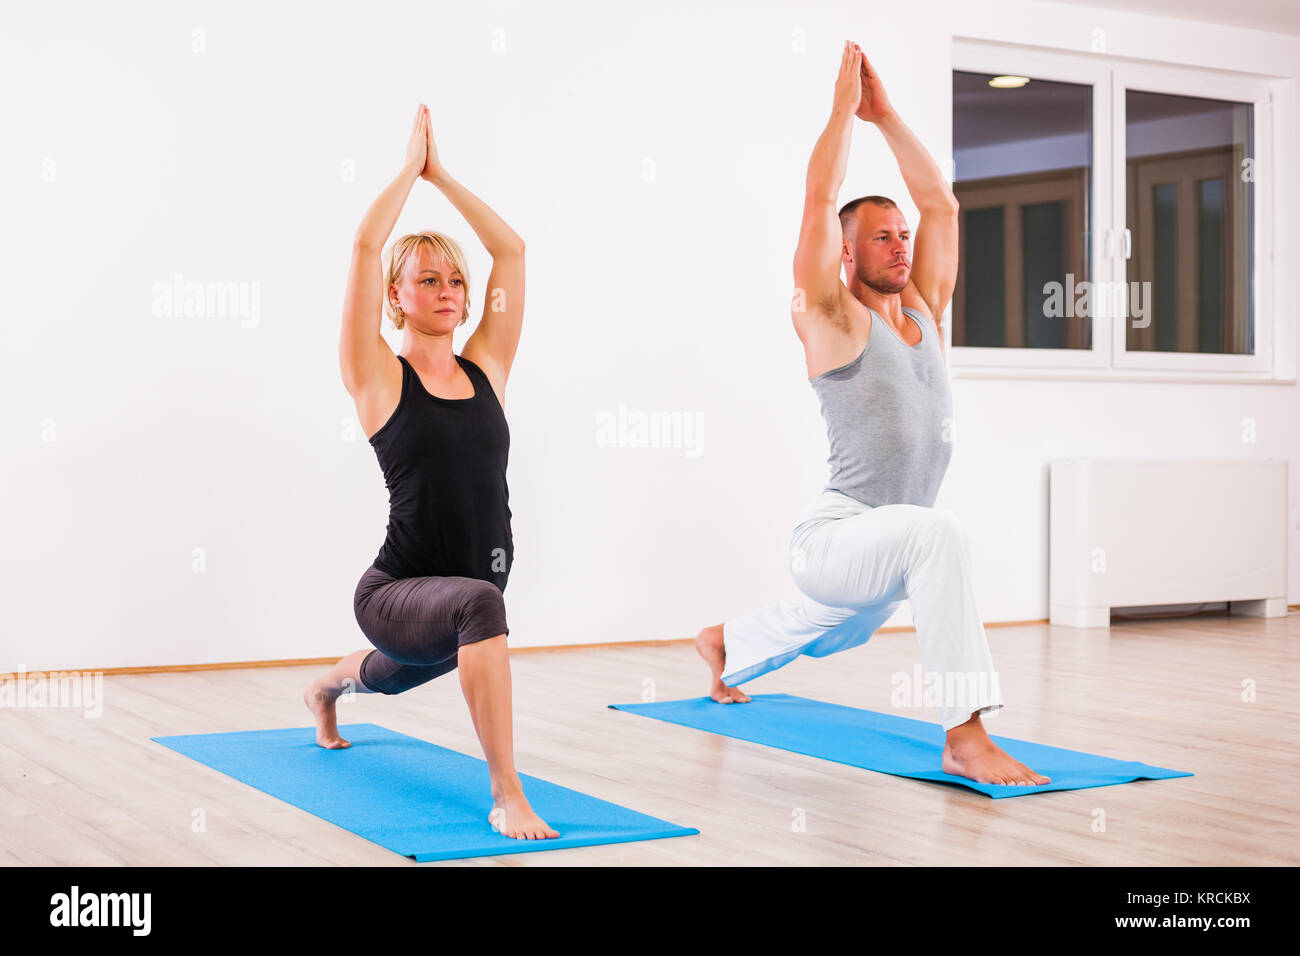What is the name of the yoga pose? The individuals in the image are performing the 'Anjaneyasana', also known as the 'Crescent Lunge'. This graceful pose is not just about physical appearance; it targets the thighs, groin, and hip flexors for a deep stretch, while expanding the lung capacity and enhancing the shoulders' flexibility. By aligning the arms and touching the palms above the head, practitioners enhance their balance and centering, making it an excellent addition to any yoga sequence for its profound impact on both body strength and mindfulness. 